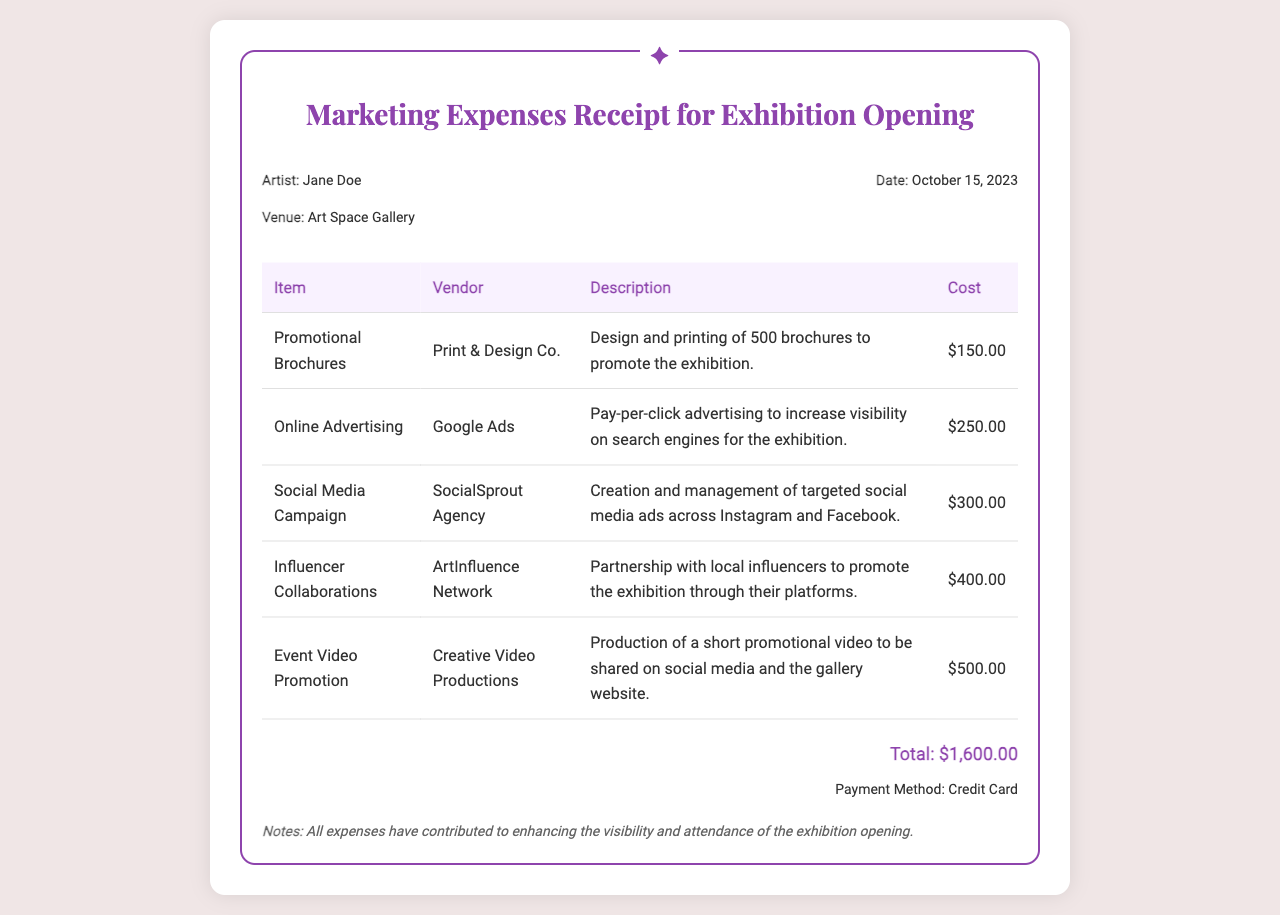What is the total cost of marketing expenses? The total cost is found at the bottom of the receipt, which adds up all listed expenses.
Answer: $1,600.00 Who is the artist associated with this receipt? The artist's name is mentioned at the top under "Artist."
Answer: Jane Doe What vendor provided the promotional brochures? The vendor's name is listed in the table under "Vendor" for the corresponding item.
Answer: Print & Design Co How much was spent on the event video promotion? The cost is indicated in the table under "Cost" for that specific item.
Answer: $500.00 What is the date of the receipt? The date is stated in the header section of the receipt.
Answer: October 15, 2023 Which agency managed the social media campaign? The agency's name can be found in the "Vendor" column for that particular item.
Answer: SocialSprout Agency What is noted about the expenses? The notes section provides information on how the expenses were intended to impact the exhibition.
Answer: Enhance visibility and attendance How many brochures were printed? The quantity is described in the "Description" for the promotional brochures item.
Answer: 500 brochures Which payment method was used? The payment method is specified in the "Payment Method" section of the receipt.
Answer: Credit Card 